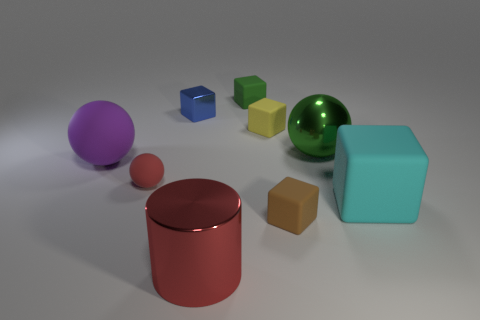Subtract all big purple balls. How many balls are left? 2 Subtract 1 blocks. How many blocks are left? 4 Subtract all blue blocks. How many blocks are left? 4 Subtract all cubes. How many objects are left? 4 Add 9 blue metallic blocks. How many blue metallic blocks are left? 10 Add 3 large blue metal cylinders. How many large blue metal cylinders exist? 3 Subtract 0 yellow cylinders. How many objects are left? 9 Subtract all yellow spheres. Subtract all red cylinders. How many spheres are left? 3 Subtract all red objects. Subtract all tiny green objects. How many objects are left? 6 